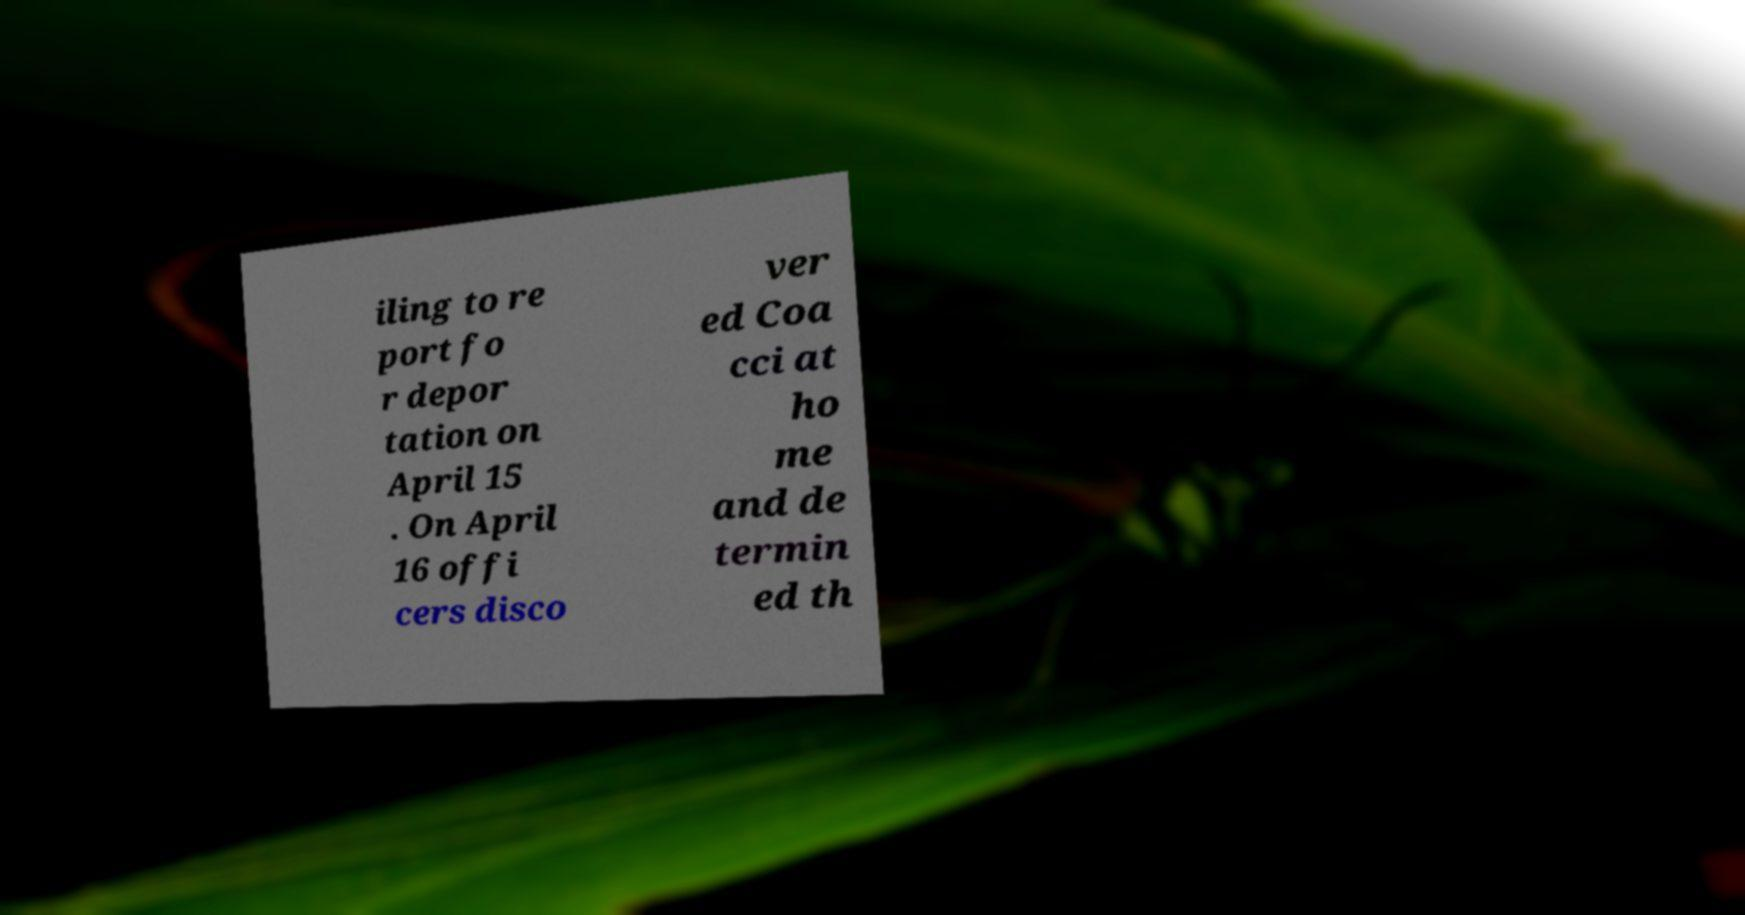Could you extract and type out the text from this image? iling to re port fo r depor tation on April 15 . On April 16 offi cers disco ver ed Coa cci at ho me and de termin ed th 